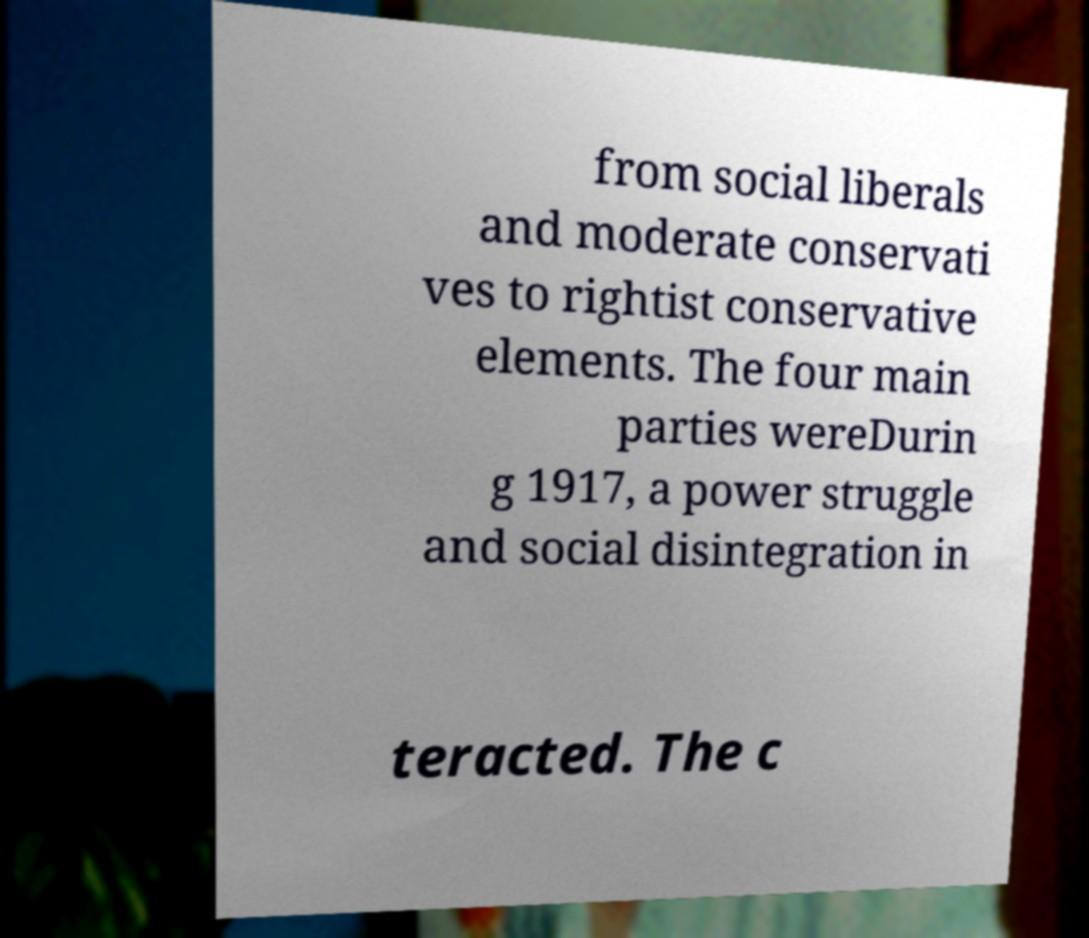Can you accurately transcribe the text from the provided image for me? from social liberals and moderate conservati ves to rightist conservative elements. The four main parties wereDurin g 1917, a power struggle and social disintegration in teracted. The c 